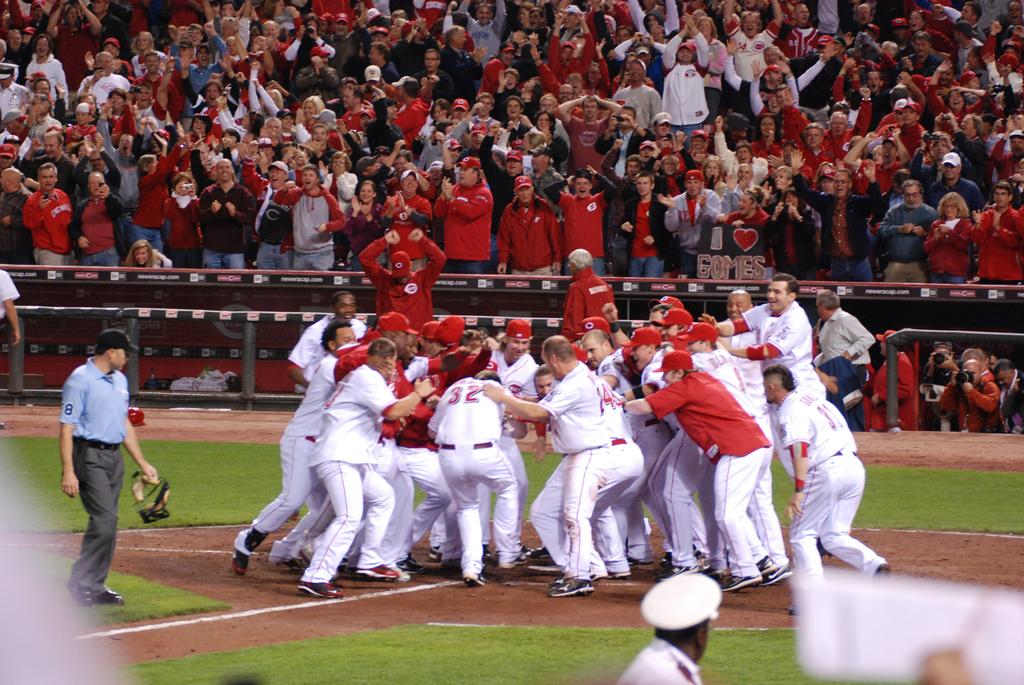Who does the sign i nthe crowd say that she loves?
Provide a short and direct response. Gomes. 